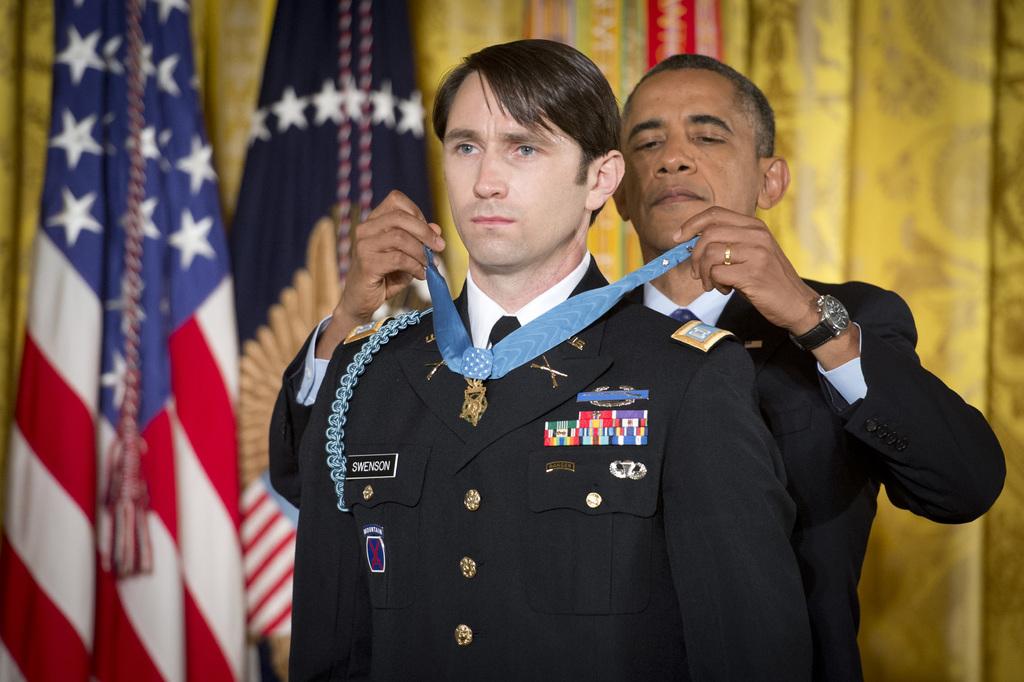What is this man's last name?
Provide a short and direct response. Swenson. Which president is this?
Give a very brief answer. Answering does not require reading text in the image. 